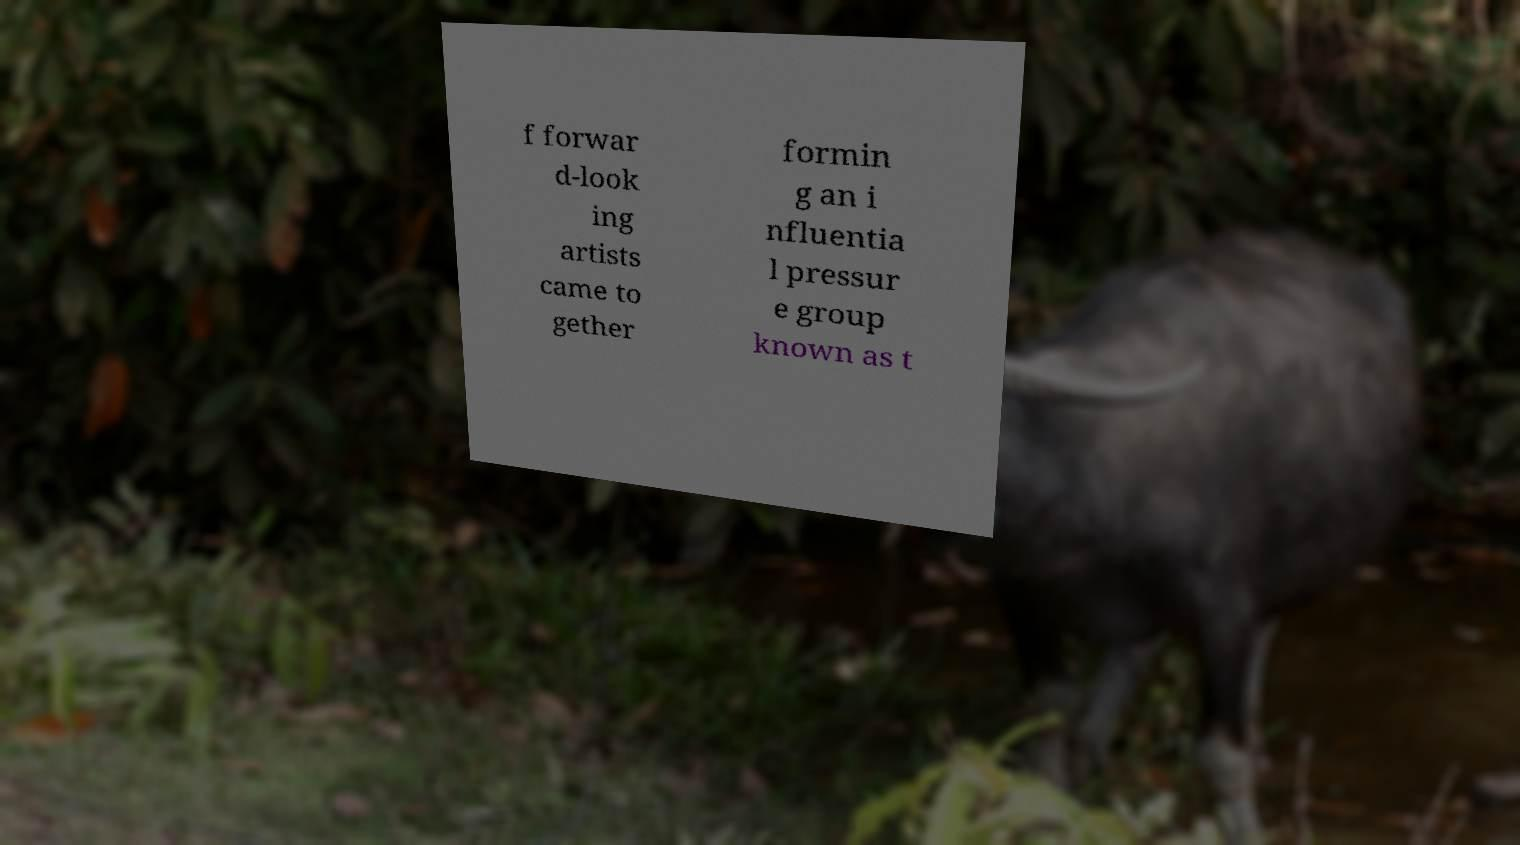Please identify and transcribe the text found in this image. f forwar d-look ing artists came to gether formin g an i nfluentia l pressur e group known as t 